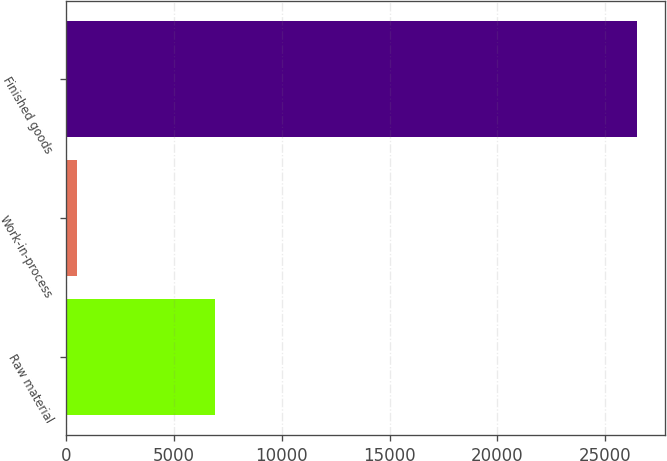Convert chart. <chart><loc_0><loc_0><loc_500><loc_500><bar_chart><fcel>Raw material<fcel>Work-in-process<fcel>Finished goods<nl><fcel>6891<fcel>509<fcel>26474<nl></chart> 